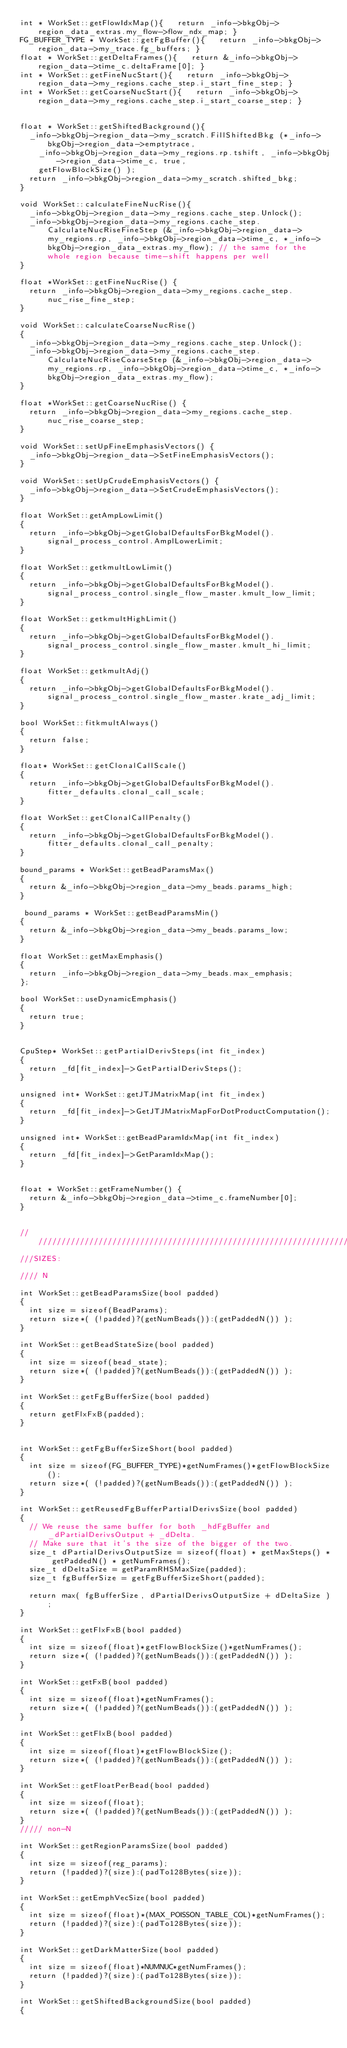Convert code to text. <code><loc_0><loc_0><loc_500><loc_500><_Cuda_>int * WorkSet::getFlowIdxMap(){   return _info->bkgObj->region_data_extras.my_flow->flow_ndx_map; }
FG_BUFFER_TYPE * WorkSet::getFgBuffer(){   return _info->bkgObj->region_data->my_trace.fg_buffers; }
float * WorkSet::getDeltaFrames(){   return &_info->bkgObj->region_data->time_c.deltaFrame[0]; }  
int * WorkSet::getFineNucStart(){   return _info->bkgObj->region_data->my_regions.cache_step.i_start_fine_step; }
int * WorkSet::getCoarseNucStart(){   return _info->bkgObj->region_data->my_regions.cache_step.i_start_coarse_step; }


float * WorkSet::getShiftedBackground(){   
  _info->bkgObj->region_data->my_scratch.FillShiftedBkg (*_info->bkgObj->region_data->emptytrace, 
    _info->bkgObj->region_data->my_regions.rp.tshift, _info->bkgObj->region_data->time_c, true,
    getFlowBlockSize() );
  return _info->bkgObj->region_data->my_scratch.shifted_bkg; 
}

void WorkSet::calculateFineNucRise(){   
  _info->bkgObj->region_data->my_regions.cache_step.Unlock();
  _info->bkgObj->region_data->my_regions.cache_step.CalculateNucRiseFineStep (&_info->bkgObj->region_data->my_regions.rp, _info->bkgObj->region_data->time_c, *_info->bkgObj->region_data_extras.my_flow); // the same for the whole region because time-shift happens per well
}

float *WorkSet::getFineNucRise() {
  return _info->bkgObj->region_data->my_regions.cache_step.nuc_rise_fine_step;
}

void WorkSet::calculateCoarseNucRise()
{
  _info->bkgObj->region_data->my_regions.cache_step.Unlock();
  _info->bkgObj->region_data->my_regions.cache_step.CalculateNucRiseCoarseStep (&_info->bkgObj->region_data->my_regions.rp, _info->bkgObj->region_data->time_c, *_info->bkgObj->region_data_extras.my_flow);
}

float *WorkSet::getCoarseNucRise() {
  return _info->bkgObj->region_data->my_regions.cache_step.nuc_rise_coarse_step;
}
 
void WorkSet::setUpFineEmphasisVectors() {
  _info->bkgObj->region_data->SetFineEmphasisVectors();
}

void WorkSet::setUpCrudeEmphasisVectors() {
  _info->bkgObj->region_data->SetCrudeEmphasisVectors();
}

float WorkSet::getAmpLowLimit() 
{ 
  return _info->bkgObj->getGlobalDefaultsForBkgModel().signal_process_control.AmplLowerLimit;
}

float WorkSet::getkmultLowLimit()
{
  return _info->bkgObj->getGlobalDefaultsForBkgModel().signal_process_control.single_flow_master.kmult_low_limit;
}

float WorkSet::getkmultHighLimit()
{
  return _info->bkgObj->getGlobalDefaultsForBkgModel().signal_process_control.single_flow_master.kmult_hi_limit;
}

float WorkSet::getkmultAdj()
{
  return _info->bkgObj->getGlobalDefaultsForBkgModel().signal_process_control.single_flow_master.krate_adj_limit;
}

bool WorkSet::fitkmultAlways()
{
  return false;
}

float* WorkSet::getClonalCallScale() 
{
  return _info->bkgObj->getGlobalDefaultsForBkgModel().fitter_defaults.clonal_call_scale;
}

float WorkSet::getClonalCallPenalty() 
{
  return _info->bkgObj->getGlobalDefaultsForBkgModel().fitter_defaults.clonal_call_penalty;
}

bound_params * WorkSet::getBeadParamsMax()
{
  return &_info->bkgObj->region_data->my_beads.params_high;
}

 bound_params * WorkSet::getBeadParamsMin()
{
  return &_info->bkgObj->region_data->my_beads.params_low;
}

float WorkSet::getMaxEmphasis()
{
  return _info->bkgObj->region_data->my_beads.max_emphasis;
};

bool WorkSet::useDynamicEmphasis()
{
  return true;
}


CpuStep* WorkSet::getPartialDerivSteps(int fit_index)
{
  return _fd[fit_index]->GetPartialDerivSteps();
}

unsigned int* WorkSet::getJTJMatrixMap(int fit_index)
{
  return _fd[fit_index]->GetJTJMatrixMapForDotProductComputation();
}

unsigned int* WorkSet::getBeadParamIdxMap(int fit_index)
{
  return _fd[fit_index]->GetParamIdxMap();
}


float * WorkSet::getFrameNumber() { 
  return &_info->bkgObj->region_data->time_c.frameNumber[0]; 
}  


//////////////////////////////////////////////////////////////////////////////////////
///SIZES:

//// N

int WorkSet::getBeadParamsSize(bool padded)
{
  int size = sizeof(BeadParams);
  return size*( (!padded)?(getNumBeads()):(getPaddedN()) ); 
}

int WorkSet::getBeadStateSize(bool padded)
{
  int size = sizeof(bead_state);
  return size*( (!padded)?(getNumBeads()):(getPaddedN()) ); 
}

int WorkSet::getFgBufferSize(bool padded)
{
  return getFlxFxB(padded);  
}


int WorkSet::getFgBufferSizeShort(bool padded)
{
  int size = sizeof(FG_BUFFER_TYPE)*getNumFrames()*getFlowBlockSize();
  return size*( (!padded)?(getNumBeads()):(getPaddedN()) ); 
}

int WorkSet::getReusedFgBufferPartialDerivsSize(bool padded)
{
  // We reuse the same buffer for both _hdFgBuffer and _dPartialDerivsOutput + _dDelta.
  // Make sure that it's the size of the bigger of the two.
  size_t dPartialDerivsOutputSize = sizeof(float) * getMaxSteps() * getPaddedN() * getNumFrames();
  size_t dDeltaSize = getParamRHSMaxSize(padded);
  size_t fgBufferSize = getFgBufferSizeShort(padded);

  return max( fgBufferSize, dPartialDerivsOutputSize + dDeltaSize );
}

int WorkSet::getFlxFxB(bool padded)
{
  int size = sizeof(float)*getFlowBlockSize()*getNumFrames();
  return size*( (!padded)?(getNumBeads()):(getPaddedN()) ); 
}

int WorkSet::getFxB(bool padded)
{
  int size = sizeof(float)*getNumFrames();
  return size*( (!padded)?(getNumBeads()):(getPaddedN()) ); 
}

int WorkSet::getFlxB(bool padded)
{
  int size = sizeof(float)*getFlowBlockSize();
  return size*( (!padded)?(getNumBeads()):(getPaddedN()) ); 
}

int WorkSet::getFloatPerBead(bool padded)
{
  int size = sizeof(float);  
  return size*( (!padded)?(getNumBeads()):(getPaddedN()) ); 
}
///// non-N

int WorkSet::getRegionParamsSize(bool padded)
{
  int size = sizeof(reg_params);
  return (!padded)?(size):(padTo128Bytes(size));
}

int WorkSet::getEmphVecSize(bool padded)
{
  int size = sizeof(float)*(MAX_POISSON_TABLE_COL)*getNumFrames();
  return (!padded)?(size):(padTo128Bytes(size));
}
 
int WorkSet::getDarkMatterSize(bool padded)
{
  int size = sizeof(float)*NUMNUC*getNumFrames();
  return (!padded)?(size):(padTo128Bytes(size));
}

int WorkSet::getShiftedBackgroundSize(bool padded)
{</code> 